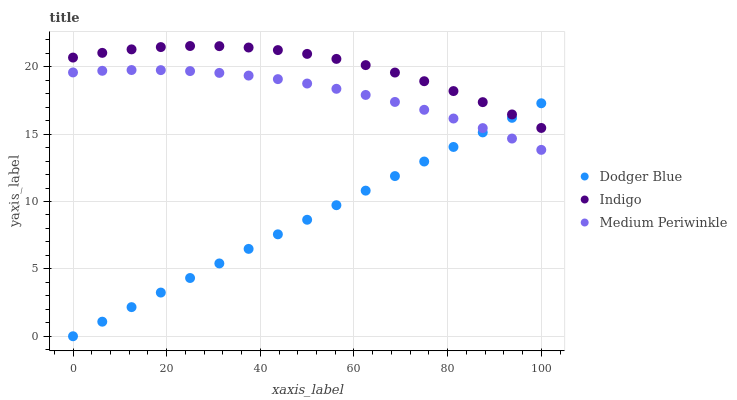Does Dodger Blue have the minimum area under the curve?
Answer yes or no. Yes. Does Indigo have the maximum area under the curve?
Answer yes or no. Yes. Does Medium Periwinkle have the minimum area under the curve?
Answer yes or no. No. Does Medium Periwinkle have the maximum area under the curve?
Answer yes or no. No. Is Dodger Blue the smoothest?
Answer yes or no. Yes. Is Indigo the roughest?
Answer yes or no. Yes. Is Medium Periwinkle the smoothest?
Answer yes or no. No. Is Medium Periwinkle the roughest?
Answer yes or no. No. Does Dodger Blue have the lowest value?
Answer yes or no. Yes. Does Medium Periwinkle have the lowest value?
Answer yes or no. No. Does Indigo have the highest value?
Answer yes or no. Yes. Does Medium Periwinkle have the highest value?
Answer yes or no. No. Is Medium Periwinkle less than Indigo?
Answer yes or no. Yes. Is Indigo greater than Medium Periwinkle?
Answer yes or no. Yes. Does Dodger Blue intersect Indigo?
Answer yes or no. Yes. Is Dodger Blue less than Indigo?
Answer yes or no. No. Is Dodger Blue greater than Indigo?
Answer yes or no. No. Does Medium Periwinkle intersect Indigo?
Answer yes or no. No. 